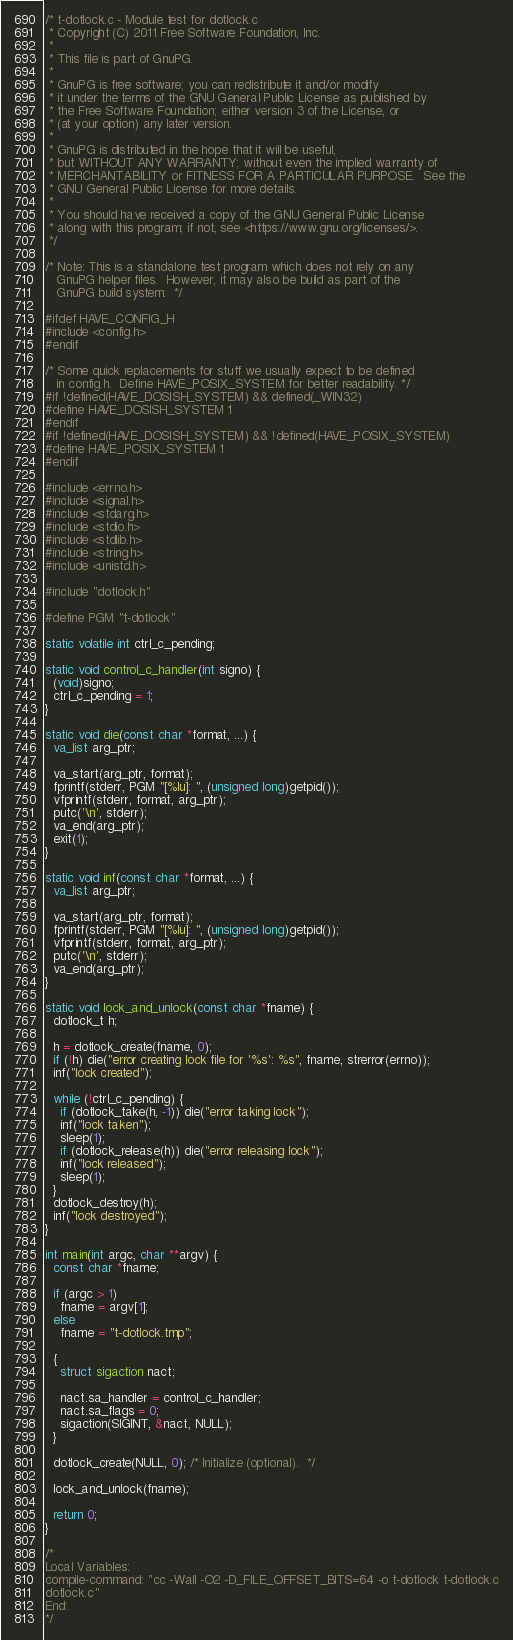<code> <loc_0><loc_0><loc_500><loc_500><_C++_>/* t-dotlock.c - Module test for dotlock.c
 * Copyright (C) 2011 Free Software Foundation, Inc.
 *
 * This file is part of GnuPG.
 *
 * GnuPG is free software; you can redistribute it and/or modify
 * it under the terms of the GNU General Public License as published by
 * the Free Software Foundation; either version 3 of the License, or
 * (at your option) any later version.
 *
 * GnuPG is distributed in the hope that it will be useful,
 * but WITHOUT ANY WARRANTY; without even the implied warranty of
 * MERCHANTABILITY or FITNESS FOR A PARTICULAR PURPOSE.  See the
 * GNU General Public License for more details.
 *
 * You should have received a copy of the GNU General Public License
 * along with this program; if not, see <https://www.gnu.org/licenses/>.
 */

/* Note: This is a standalone test program which does not rely on any
   GnuPG helper files.  However, it may also be build as part of the
   GnuPG build system.  */

#ifdef HAVE_CONFIG_H
#include <config.h>
#endif

/* Some quick replacements for stuff we usually expect to be defined
   in config.h.  Define HAVE_POSIX_SYSTEM for better readability. */
#if !defined(HAVE_DOSISH_SYSTEM) && defined(_WIN32)
#define HAVE_DOSISH_SYSTEM 1
#endif
#if !defined(HAVE_DOSISH_SYSTEM) && !defined(HAVE_POSIX_SYSTEM)
#define HAVE_POSIX_SYSTEM 1
#endif

#include <errno.h>
#include <signal.h>
#include <stdarg.h>
#include <stdio.h>
#include <stdlib.h>
#include <string.h>
#include <unistd.h>

#include "dotlock.h"

#define PGM "t-dotlock"

static volatile int ctrl_c_pending;

static void control_c_handler(int signo) {
  (void)signo;
  ctrl_c_pending = 1;
}

static void die(const char *format, ...) {
  va_list arg_ptr;

  va_start(arg_ptr, format);
  fprintf(stderr, PGM "[%lu]: ", (unsigned long)getpid());
  vfprintf(stderr, format, arg_ptr);
  putc('\n', stderr);
  va_end(arg_ptr);
  exit(1);
}

static void inf(const char *format, ...) {
  va_list arg_ptr;

  va_start(arg_ptr, format);
  fprintf(stderr, PGM "[%lu]: ", (unsigned long)getpid());
  vfprintf(stderr, format, arg_ptr);
  putc('\n', stderr);
  va_end(arg_ptr);
}

static void lock_and_unlock(const char *fname) {
  dotlock_t h;

  h = dotlock_create(fname, 0);
  if (!h) die("error creating lock file for '%s': %s", fname, strerror(errno));
  inf("lock created");

  while (!ctrl_c_pending) {
    if (dotlock_take(h, -1)) die("error taking lock");
    inf("lock taken");
    sleep(1);
    if (dotlock_release(h)) die("error releasing lock");
    inf("lock released");
    sleep(1);
  }
  dotlock_destroy(h);
  inf("lock destroyed");
}

int main(int argc, char **argv) {
  const char *fname;

  if (argc > 1)
    fname = argv[1];
  else
    fname = "t-dotlock.tmp";

  {
    struct sigaction nact;

    nact.sa_handler = control_c_handler;
    nact.sa_flags = 0;
    sigaction(SIGINT, &nact, NULL);
  }

  dotlock_create(NULL, 0); /* Initialize (optional).  */

  lock_and_unlock(fname);

  return 0;
}

/*
Local Variables:
compile-command: "cc -Wall -O2 -D_FILE_OFFSET_BITS=64 -o t-dotlock t-dotlock.c
dotlock.c"
End:
*/
</code> 